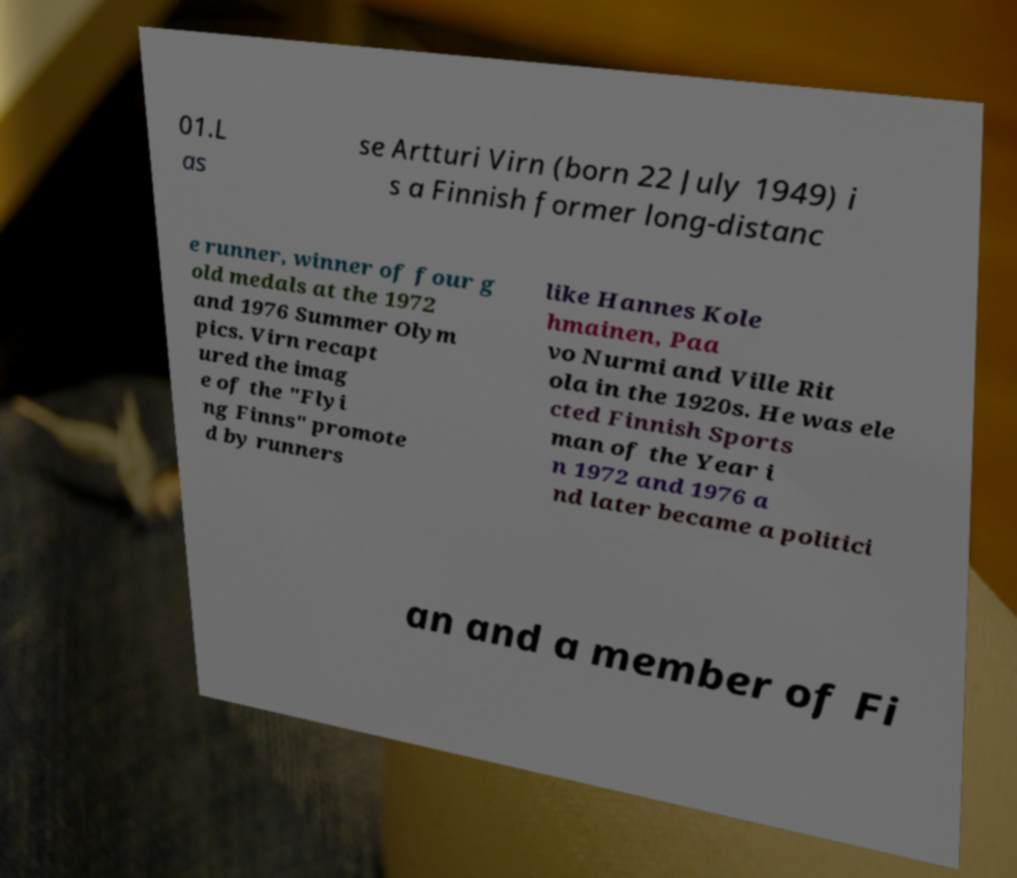I need the written content from this picture converted into text. Can you do that? 01.L as se Artturi Virn (born 22 July 1949) i s a Finnish former long-distanc e runner, winner of four g old medals at the 1972 and 1976 Summer Olym pics. Virn recapt ured the imag e of the "Flyi ng Finns" promote d by runners like Hannes Kole hmainen, Paa vo Nurmi and Ville Rit ola in the 1920s. He was ele cted Finnish Sports man of the Year i n 1972 and 1976 a nd later became a politici an and a member of Fi 